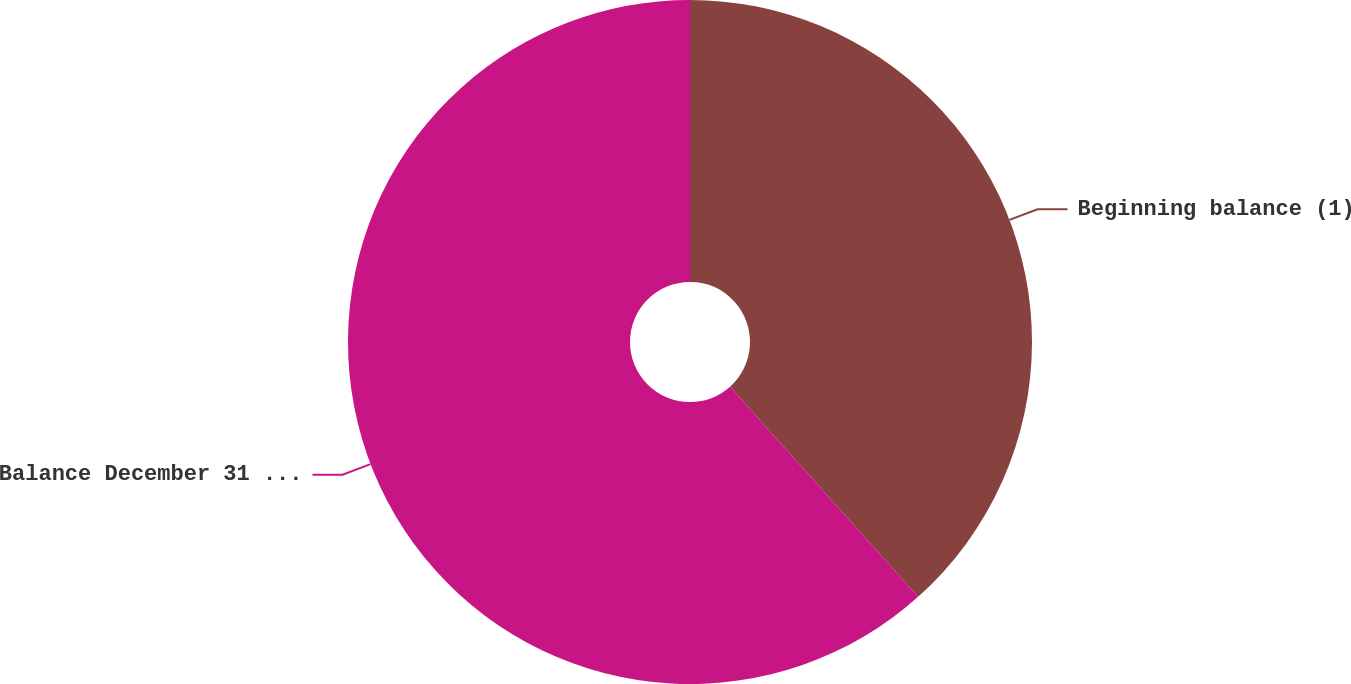<chart> <loc_0><loc_0><loc_500><loc_500><pie_chart><fcel>Beginning balance (1)<fcel>Balance December 31 2008 (3)<nl><fcel>38.38%<fcel>61.62%<nl></chart> 